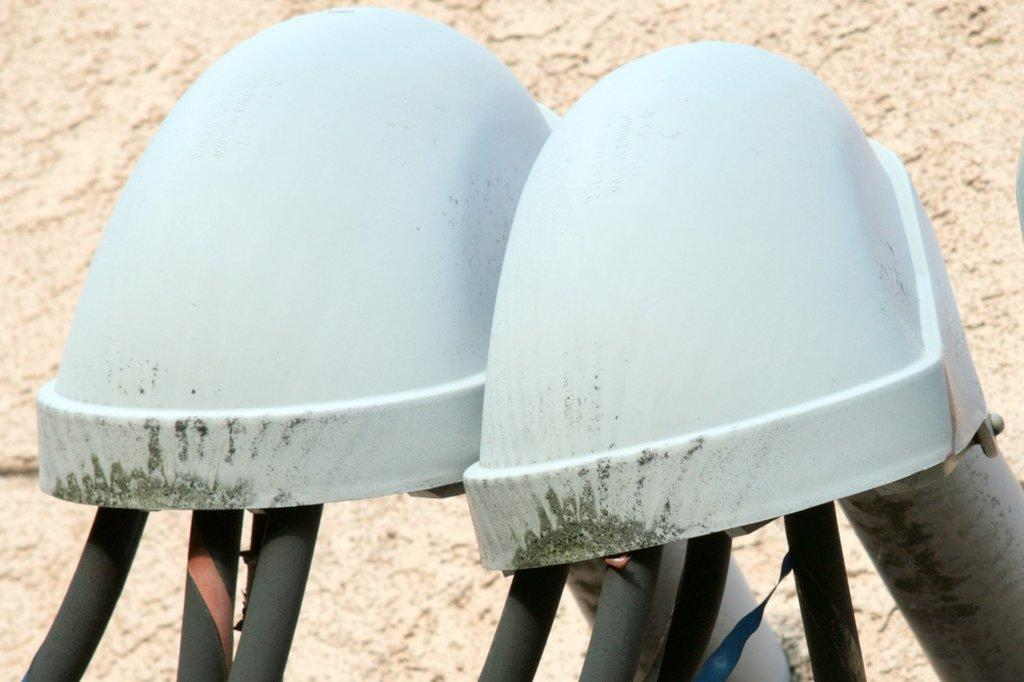What are the two white color objects in the center of the image? There are two white color objects in the center of the image, but their specific nature is not mentioned in the facts. What can be seen in the background of the image? In the background of the image, there are pipes, a bolt, and a wall. Can you describe the pipes in the background? The facts do not provide any details about the pipes, so we cannot describe them further. How many girls are present in the image? There is no mention of girls in the image, so we cannot answer this question. 